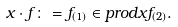<formula> <loc_0><loc_0><loc_500><loc_500>x \cdot f \colon = f _ { ( 1 ) } \in p r o d { x } { f _ { ( 2 ) } } .</formula> 